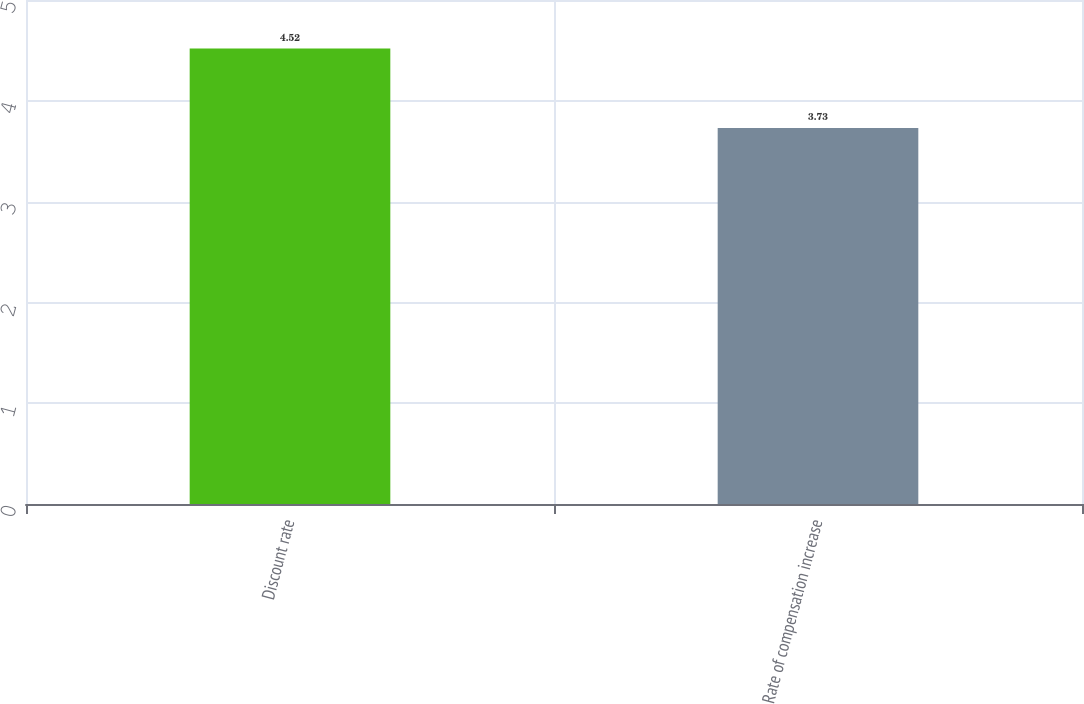Convert chart to OTSL. <chart><loc_0><loc_0><loc_500><loc_500><bar_chart><fcel>Discount rate<fcel>Rate of compensation increase<nl><fcel>4.52<fcel>3.73<nl></chart> 